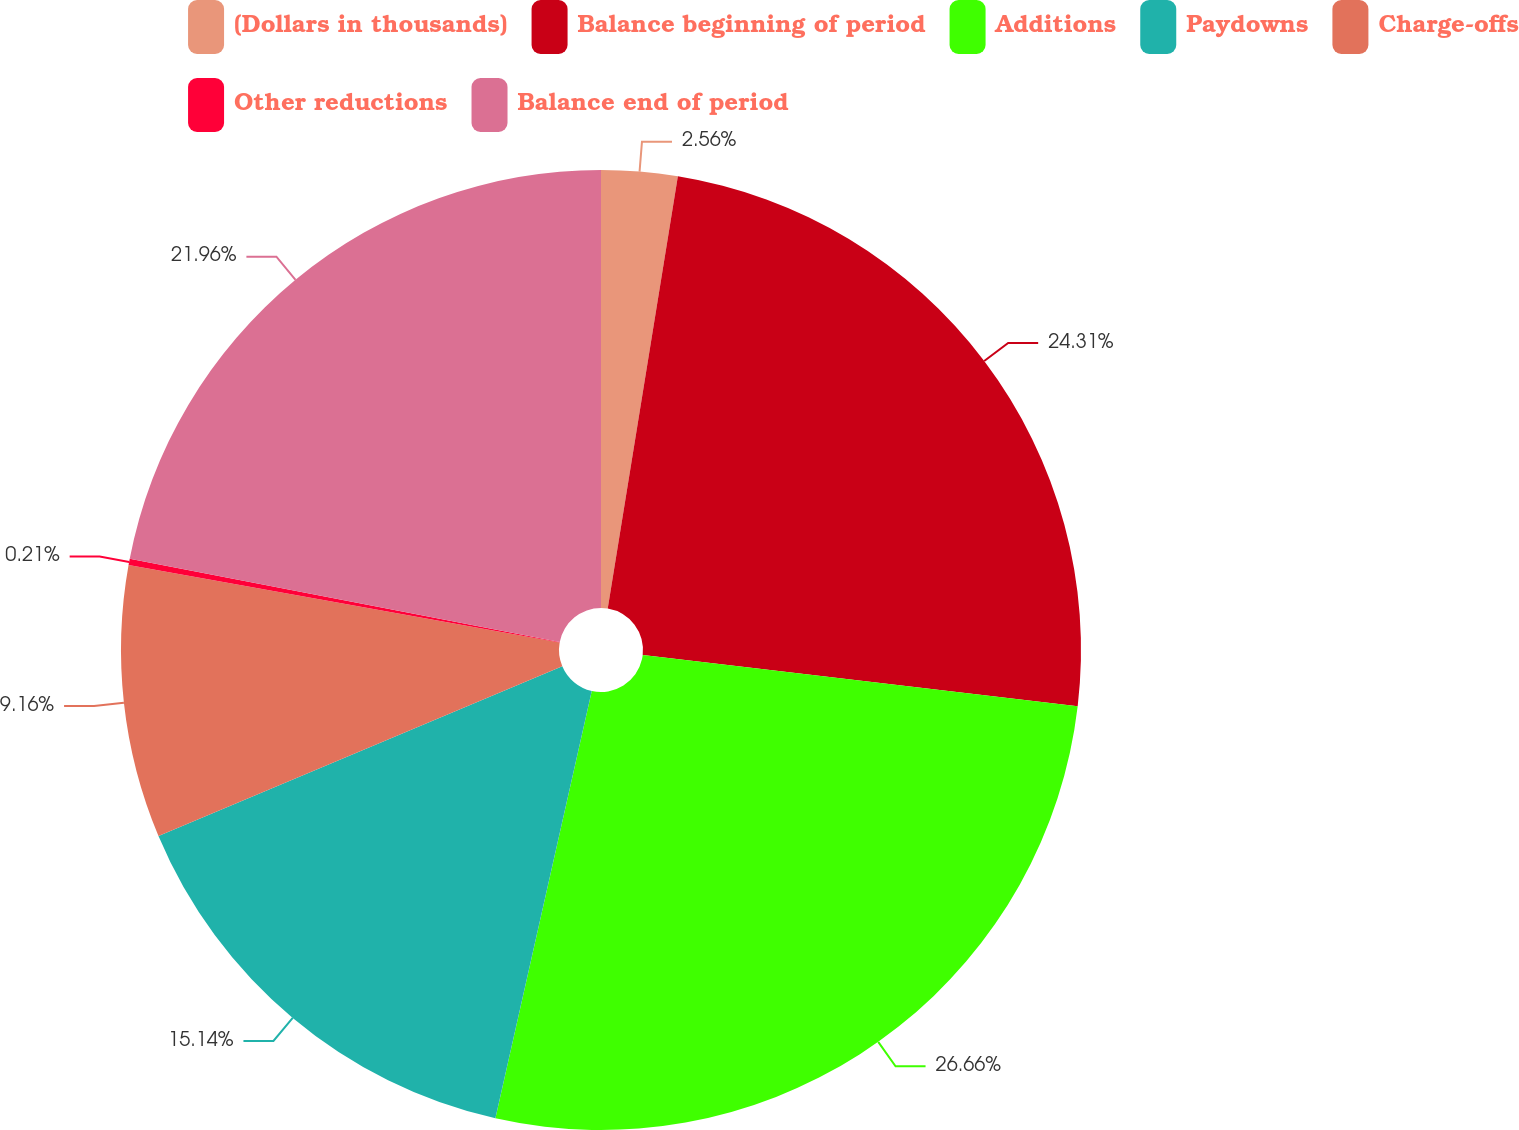Convert chart. <chart><loc_0><loc_0><loc_500><loc_500><pie_chart><fcel>(Dollars in thousands)<fcel>Balance beginning of period<fcel>Additions<fcel>Paydowns<fcel>Charge-offs<fcel>Other reductions<fcel>Balance end of period<nl><fcel>2.56%<fcel>24.31%<fcel>26.66%<fcel>15.14%<fcel>9.16%<fcel>0.21%<fcel>21.96%<nl></chart> 